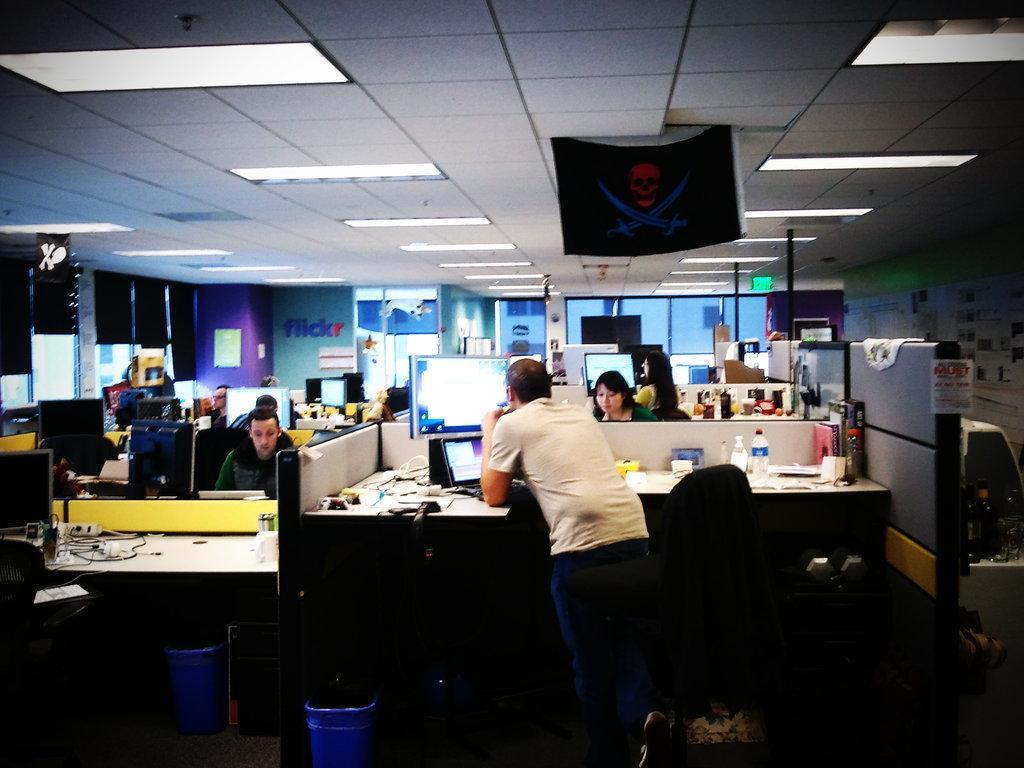Could you give a brief overview of what you see in this image? In this image, there are a few people. We can see some desks with objects like screens, wires. We can see the ground with some objects. We can also see the wall with some posters. We can also see some boards with text and images. We can see the roof with some lights and an object. 